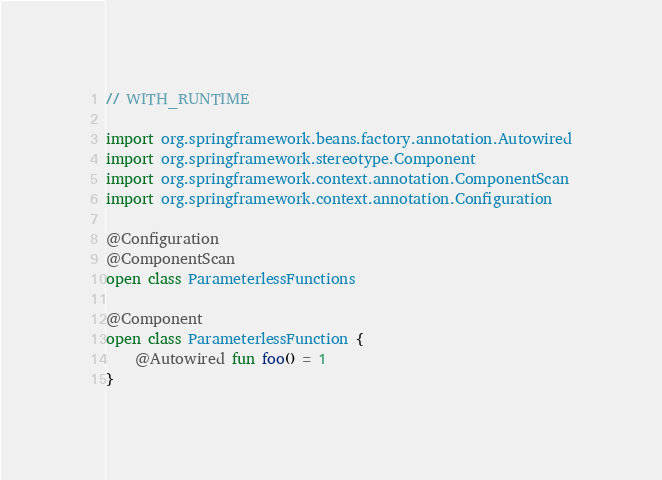<code> <loc_0><loc_0><loc_500><loc_500><_Kotlin_>
// WITH_RUNTIME

import org.springframework.beans.factory.annotation.Autowired
import org.springframework.stereotype.Component
import org.springframework.context.annotation.ComponentScan
import org.springframework.context.annotation.Configuration

@Configuration
@ComponentScan
open class ParameterlessFunctions

@Component
open class ParameterlessFunction {
    @Autowired fun foo() = 1
}</code> 